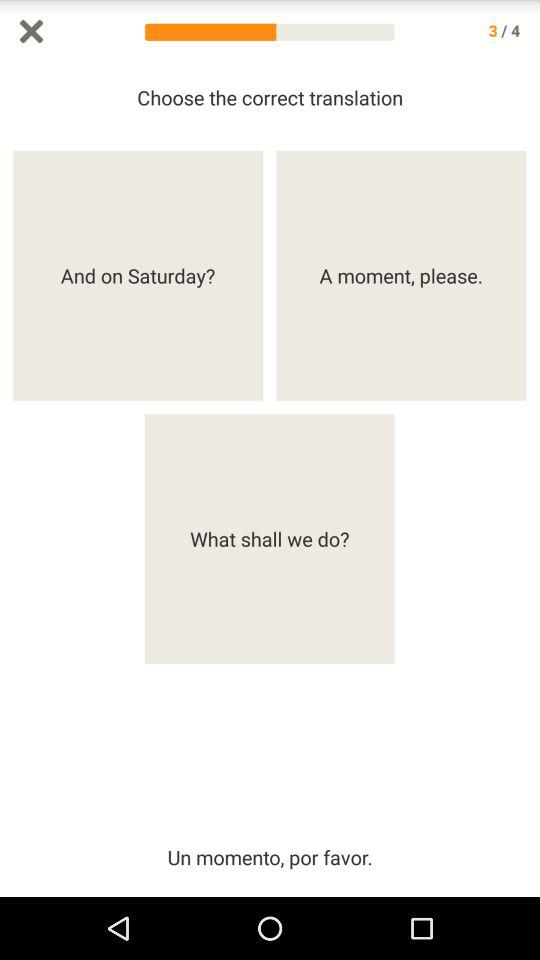What is the current question number? The current question number is 3. 